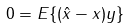Convert formula to latex. <formula><loc_0><loc_0><loc_500><loc_500>0 = E \{ ( \hat { x } - x ) y \}</formula> 